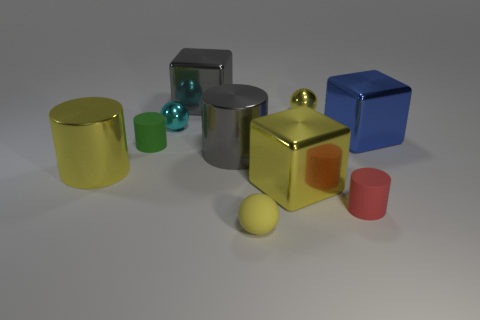Subtract 1 cylinders. How many cylinders are left? 3 Subtract all cubes. How many objects are left? 7 Subtract all yellow cylinders. Subtract all green matte cylinders. How many objects are left? 8 Add 4 gray metallic cubes. How many gray metallic cubes are left? 5 Add 2 cyan things. How many cyan things exist? 3 Subtract 1 gray cubes. How many objects are left? 9 